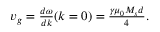Convert formula to latex. <formula><loc_0><loc_0><loc_500><loc_500>\begin{array} { r } { v _ { g } = \frac { d \omega } { d k } ( k = 0 ) = \frac { \gamma \mu _ { 0 } M _ { s } d } { 4 } . } \end{array}</formula> 